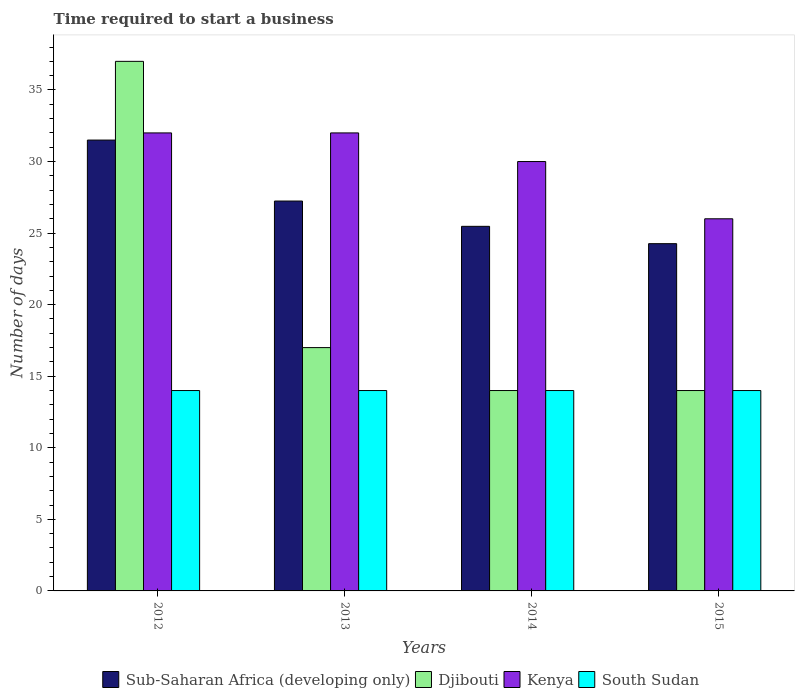Are the number of bars on each tick of the X-axis equal?
Your answer should be very brief. Yes. How many bars are there on the 2nd tick from the left?
Your answer should be very brief. 4. What is the label of the 1st group of bars from the left?
Offer a terse response. 2012. What is the number of days required to start a business in Kenya in 2015?
Provide a short and direct response. 26. Across all years, what is the maximum number of days required to start a business in Sub-Saharan Africa (developing only)?
Offer a terse response. 31.5. In which year was the number of days required to start a business in South Sudan minimum?
Keep it short and to the point. 2012. What is the total number of days required to start a business in Kenya in the graph?
Make the answer very short. 120. What is the difference between the number of days required to start a business in Kenya in 2012 and that in 2014?
Offer a terse response. 2. What is the difference between the number of days required to start a business in South Sudan in 2014 and the number of days required to start a business in Sub-Saharan Africa (developing only) in 2012?
Make the answer very short. -17.5. What is the average number of days required to start a business in Djibouti per year?
Keep it short and to the point. 20.5. In the year 2014, what is the difference between the number of days required to start a business in Sub-Saharan Africa (developing only) and number of days required to start a business in Kenya?
Provide a short and direct response. -4.53. What is the ratio of the number of days required to start a business in Kenya in 2012 to that in 2015?
Your response must be concise. 1.23. Is the number of days required to start a business in South Sudan in 2013 less than that in 2015?
Make the answer very short. No. What is the difference between the highest and the second highest number of days required to start a business in Sub-Saharan Africa (developing only)?
Your response must be concise. 4.26. What is the difference between the highest and the lowest number of days required to start a business in Djibouti?
Keep it short and to the point. 23. In how many years, is the number of days required to start a business in Sub-Saharan Africa (developing only) greater than the average number of days required to start a business in Sub-Saharan Africa (developing only) taken over all years?
Offer a very short reply. 2. What does the 2nd bar from the left in 2014 represents?
Offer a terse response. Djibouti. What does the 1st bar from the right in 2013 represents?
Your response must be concise. South Sudan. Is it the case that in every year, the sum of the number of days required to start a business in South Sudan and number of days required to start a business in Kenya is greater than the number of days required to start a business in Sub-Saharan Africa (developing only)?
Provide a succinct answer. Yes. How many bars are there?
Ensure brevity in your answer.  16. What is the difference between two consecutive major ticks on the Y-axis?
Your answer should be compact. 5. Does the graph contain any zero values?
Provide a short and direct response. No. How many legend labels are there?
Your answer should be very brief. 4. What is the title of the graph?
Provide a short and direct response. Time required to start a business. Does "Samoa" appear as one of the legend labels in the graph?
Offer a terse response. No. What is the label or title of the X-axis?
Provide a succinct answer. Years. What is the label or title of the Y-axis?
Offer a very short reply. Number of days. What is the Number of days of Sub-Saharan Africa (developing only) in 2012?
Offer a terse response. 31.5. What is the Number of days in Djibouti in 2012?
Your answer should be very brief. 37. What is the Number of days in Sub-Saharan Africa (developing only) in 2013?
Make the answer very short. 27.24. What is the Number of days of Kenya in 2013?
Offer a terse response. 32. What is the Number of days of South Sudan in 2013?
Your answer should be compact. 14. What is the Number of days in Sub-Saharan Africa (developing only) in 2014?
Give a very brief answer. 25.47. What is the Number of days in Djibouti in 2014?
Make the answer very short. 14. What is the Number of days in Sub-Saharan Africa (developing only) in 2015?
Your answer should be very brief. 24.26. What is the Number of days in Kenya in 2015?
Offer a terse response. 26. Across all years, what is the maximum Number of days in Sub-Saharan Africa (developing only)?
Provide a succinct answer. 31.5. Across all years, what is the minimum Number of days of Sub-Saharan Africa (developing only)?
Ensure brevity in your answer.  24.26. Across all years, what is the minimum Number of days of Djibouti?
Your answer should be very brief. 14. What is the total Number of days in Sub-Saharan Africa (developing only) in the graph?
Your answer should be compact. 108.48. What is the total Number of days of Kenya in the graph?
Your answer should be very brief. 120. What is the total Number of days of South Sudan in the graph?
Offer a terse response. 56. What is the difference between the Number of days of Sub-Saharan Africa (developing only) in 2012 and that in 2013?
Make the answer very short. 4.26. What is the difference between the Number of days in Djibouti in 2012 and that in 2013?
Ensure brevity in your answer.  20. What is the difference between the Number of days of South Sudan in 2012 and that in 2013?
Keep it short and to the point. 0. What is the difference between the Number of days of Sub-Saharan Africa (developing only) in 2012 and that in 2014?
Your answer should be very brief. 6.03. What is the difference between the Number of days in Kenya in 2012 and that in 2014?
Make the answer very short. 2. What is the difference between the Number of days of Sub-Saharan Africa (developing only) in 2012 and that in 2015?
Give a very brief answer. 7.24. What is the difference between the Number of days of Sub-Saharan Africa (developing only) in 2013 and that in 2014?
Make the answer very short. 1.77. What is the difference between the Number of days of Djibouti in 2013 and that in 2014?
Your response must be concise. 3. What is the difference between the Number of days in South Sudan in 2013 and that in 2014?
Make the answer very short. 0. What is the difference between the Number of days of Sub-Saharan Africa (developing only) in 2013 and that in 2015?
Offer a very short reply. 2.98. What is the difference between the Number of days of Sub-Saharan Africa (developing only) in 2014 and that in 2015?
Provide a succinct answer. 1.21. What is the difference between the Number of days of Sub-Saharan Africa (developing only) in 2012 and the Number of days of South Sudan in 2013?
Your response must be concise. 17.5. What is the difference between the Number of days in Djibouti in 2012 and the Number of days in Kenya in 2013?
Ensure brevity in your answer.  5. What is the difference between the Number of days in Djibouti in 2012 and the Number of days in Kenya in 2014?
Give a very brief answer. 7. What is the difference between the Number of days in Djibouti in 2012 and the Number of days in South Sudan in 2014?
Give a very brief answer. 23. What is the difference between the Number of days of Kenya in 2012 and the Number of days of South Sudan in 2014?
Keep it short and to the point. 18. What is the difference between the Number of days in Sub-Saharan Africa (developing only) in 2012 and the Number of days in Djibouti in 2015?
Your answer should be very brief. 17.5. What is the difference between the Number of days of Sub-Saharan Africa (developing only) in 2012 and the Number of days of South Sudan in 2015?
Offer a very short reply. 17.5. What is the difference between the Number of days of Djibouti in 2012 and the Number of days of South Sudan in 2015?
Give a very brief answer. 23. What is the difference between the Number of days in Sub-Saharan Africa (developing only) in 2013 and the Number of days in Djibouti in 2014?
Make the answer very short. 13.24. What is the difference between the Number of days of Sub-Saharan Africa (developing only) in 2013 and the Number of days of Kenya in 2014?
Offer a very short reply. -2.76. What is the difference between the Number of days in Sub-Saharan Africa (developing only) in 2013 and the Number of days in South Sudan in 2014?
Make the answer very short. 13.24. What is the difference between the Number of days in Djibouti in 2013 and the Number of days in Kenya in 2014?
Ensure brevity in your answer.  -13. What is the difference between the Number of days of Djibouti in 2013 and the Number of days of South Sudan in 2014?
Your answer should be very brief. 3. What is the difference between the Number of days in Kenya in 2013 and the Number of days in South Sudan in 2014?
Offer a terse response. 18. What is the difference between the Number of days in Sub-Saharan Africa (developing only) in 2013 and the Number of days in Djibouti in 2015?
Your answer should be very brief. 13.24. What is the difference between the Number of days of Sub-Saharan Africa (developing only) in 2013 and the Number of days of Kenya in 2015?
Keep it short and to the point. 1.24. What is the difference between the Number of days in Sub-Saharan Africa (developing only) in 2013 and the Number of days in South Sudan in 2015?
Keep it short and to the point. 13.24. What is the difference between the Number of days of Djibouti in 2013 and the Number of days of Kenya in 2015?
Your response must be concise. -9. What is the difference between the Number of days of Sub-Saharan Africa (developing only) in 2014 and the Number of days of Djibouti in 2015?
Ensure brevity in your answer.  11.47. What is the difference between the Number of days of Sub-Saharan Africa (developing only) in 2014 and the Number of days of Kenya in 2015?
Your response must be concise. -0.53. What is the difference between the Number of days of Sub-Saharan Africa (developing only) in 2014 and the Number of days of South Sudan in 2015?
Make the answer very short. 11.47. What is the difference between the Number of days of Kenya in 2014 and the Number of days of South Sudan in 2015?
Your answer should be compact. 16. What is the average Number of days in Sub-Saharan Africa (developing only) per year?
Give a very brief answer. 27.12. What is the average Number of days of South Sudan per year?
Provide a succinct answer. 14. In the year 2012, what is the difference between the Number of days of Sub-Saharan Africa (developing only) and Number of days of Kenya?
Offer a terse response. -0.5. In the year 2012, what is the difference between the Number of days of Sub-Saharan Africa (developing only) and Number of days of South Sudan?
Your answer should be very brief. 17.5. In the year 2013, what is the difference between the Number of days in Sub-Saharan Africa (developing only) and Number of days in Djibouti?
Offer a terse response. 10.24. In the year 2013, what is the difference between the Number of days of Sub-Saharan Africa (developing only) and Number of days of Kenya?
Ensure brevity in your answer.  -4.76. In the year 2013, what is the difference between the Number of days of Sub-Saharan Africa (developing only) and Number of days of South Sudan?
Provide a succinct answer. 13.24. In the year 2013, what is the difference between the Number of days of Kenya and Number of days of South Sudan?
Provide a succinct answer. 18. In the year 2014, what is the difference between the Number of days of Sub-Saharan Africa (developing only) and Number of days of Djibouti?
Ensure brevity in your answer.  11.47. In the year 2014, what is the difference between the Number of days of Sub-Saharan Africa (developing only) and Number of days of Kenya?
Give a very brief answer. -4.53. In the year 2014, what is the difference between the Number of days of Sub-Saharan Africa (developing only) and Number of days of South Sudan?
Your answer should be compact. 11.47. In the year 2014, what is the difference between the Number of days in Djibouti and Number of days in South Sudan?
Provide a short and direct response. 0. In the year 2015, what is the difference between the Number of days in Sub-Saharan Africa (developing only) and Number of days in Djibouti?
Your answer should be compact. 10.26. In the year 2015, what is the difference between the Number of days of Sub-Saharan Africa (developing only) and Number of days of Kenya?
Offer a very short reply. -1.74. In the year 2015, what is the difference between the Number of days of Sub-Saharan Africa (developing only) and Number of days of South Sudan?
Keep it short and to the point. 10.26. In the year 2015, what is the difference between the Number of days in Djibouti and Number of days in Kenya?
Offer a very short reply. -12. In the year 2015, what is the difference between the Number of days of Djibouti and Number of days of South Sudan?
Make the answer very short. 0. What is the ratio of the Number of days of Sub-Saharan Africa (developing only) in 2012 to that in 2013?
Your response must be concise. 1.16. What is the ratio of the Number of days in Djibouti in 2012 to that in 2013?
Provide a succinct answer. 2.18. What is the ratio of the Number of days of South Sudan in 2012 to that in 2013?
Offer a terse response. 1. What is the ratio of the Number of days in Sub-Saharan Africa (developing only) in 2012 to that in 2014?
Provide a succinct answer. 1.24. What is the ratio of the Number of days in Djibouti in 2012 to that in 2014?
Provide a short and direct response. 2.64. What is the ratio of the Number of days of Kenya in 2012 to that in 2014?
Provide a succinct answer. 1.07. What is the ratio of the Number of days in South Sudan in 2012 to that in 2014?
Give a very brief answer. 1. What is the ratio of the Number of days in Sub-Saharan Africa (developing only) in 2012 to that in 2015?
Ensure brevity in your answer.  1.3. What is the ratio of the Number of days in Djibouti in 2012 to that in 2015?
Your answer should be compact. 2.64. What is the ratio of the Number of days of Kenya in 2012 to that in 2015?
Ensure brevity in your answer.  1.23. What is the ratio of the Number of days in Sub-Saharan Africa (developing only) in 2013 to that in 2014?
Your answer should be compact. 1.07. What is the ratio of the Number of days of Djibouti in 2013 to that in 2014?
Give a very brief answer. 1.21. What is the ratio of the Number of days in Kenya in 2013 to that in 2014?
Ensure brevity in your answer.  1.07. What is the ratio of the Number of days of Sub-Saharan Africa (developing only) in 2013 to that in 2015?
Ensure brevity in your answer.  1.12. What is the ratio of the Number of days of Djibouti in 2013 to that in 2015?
Provide a short and direct response. 1.21. What is the ratio of the Number of days in Kenya in 2013 to that in 2015?
Your response must be concise. 1.23. What is the ratio of the Number of days in Sub-Saharan Africa (developing only) in 2014 to that in 2015?
Your answer should be compact. 1.05. What is the ratio of the Number of days of Djibouti in 2014 to that in 2015?
Provide a succinct answer. 1. What is the ratio of the Number of days in Kenya in 2014 to that in 2015?
Your response must be concise. 1.15. What is the difference between the highest and the second highest Number of days in Sub-Saharan Africa (developing only)?
Provide a succinct answer. 4.26. What is the difference between the highest and the second highest Number of days in Djibouti?
Keep it short and to the point. 20. What is the difference between the highest and the second highest Number of days of Kenya?
Offer a terse response. 0. What is the difference between the highest and the lowest Number of days of Sub-Saharan Africa (developing only)?
Ensure brevity in your answer.  7.24. What is the difference between the highest and the lowest Number of days of Djibouti?
Offer a very short reply. 23. 